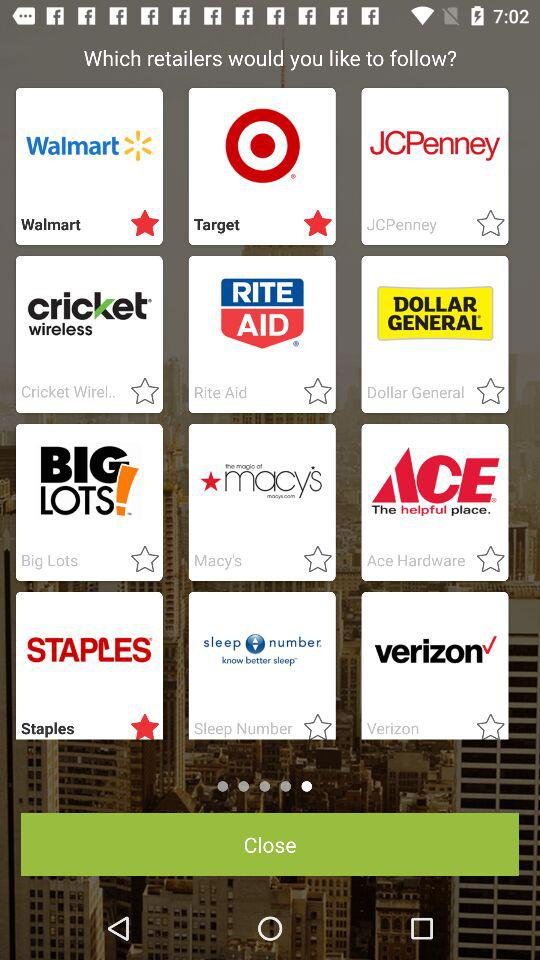Which retailers are shown? The shown retailers are "Walmart", "Target", "JCPenney", "Cricket Wirel..", "Rite Aid", "Dollar General", "Big Lots", "Macy's", "Ace Hardware", "Staples", "Sleep Number" and "Verizon". 